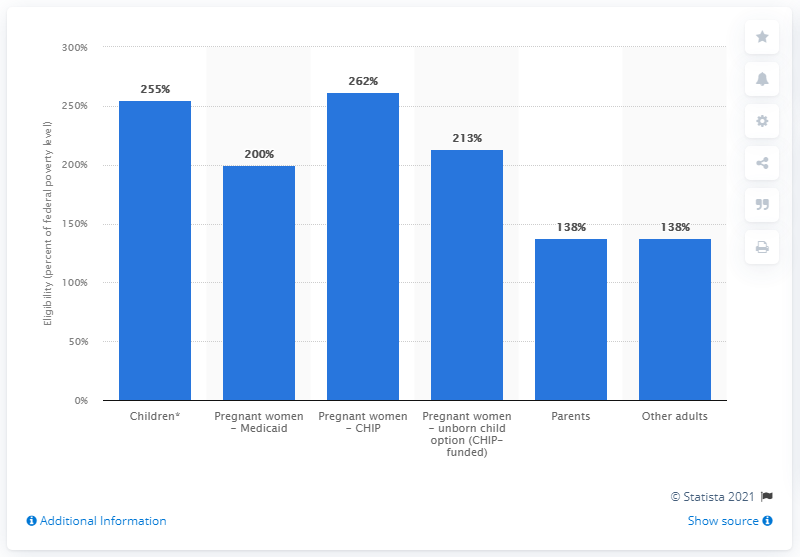Give some essential details in this illustration. The minimum eligibility threshold for adults in states with expanded coverage is 138. 